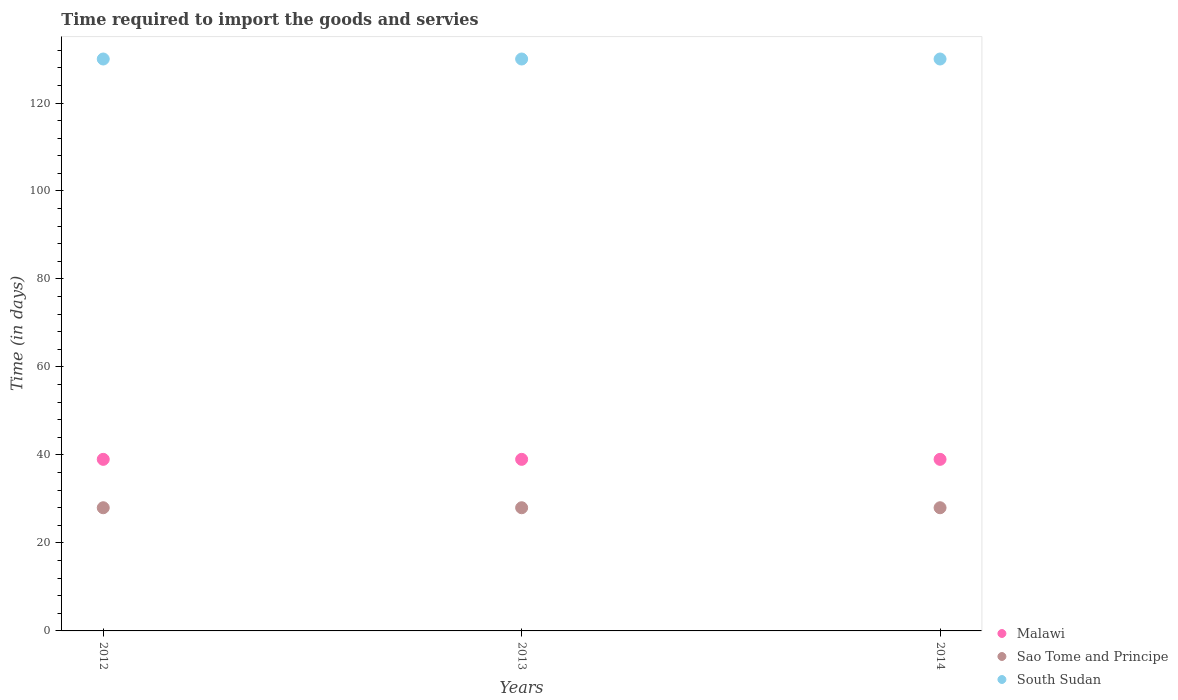How many different coloured dotlines are there?
Provide a short and direct response. 3. Is the number of dotlines equal to the number of legend labels?
Provide a short and direct response. Yes. What is the number of days required to import the goods and services in Malawi in 2014?
Your answer should be compact. 39. Across all years, what is the maximum number of days required to import the goods and services in South Sudan?
Your answer should be compact. 130. Across all years, what is the minimum number of days required to import the goods and services in South Sudan?
Give a very brief answer. 130. What is the total number of days required to import the goods and services in Sao Tome and Principe in the graph?
Offer a terse response. 84. What is the difference between the number of days required to import the goods and services in South Sudan in 2013 and that in 2014?
Make the answer very short. 0. What is the difference between the number of days required to import the goods and services in Malawi in 2014 and the number of days required to import the goods and services in Sao Tome and Principe in 2012?
Ensure brevity in your answer.  11. What is the average number of days required to import the goods and services in Sao Tome and Principe per year?
Offer a very short reply. 28. In the year 2012, what is the difference between the number of days required to import the goods and services in Malawi and number of days required to import the goods and services in South Sudan?
Provide a succinct answer. -91. Is the sum of the number of days required to import the goods and services in Malawi in 2012 and 2013 greater than the maximum number of days required to import the goods and services in Sao Tome and Principe across all years?
Provide a succinct answer. Yes. Is the number of days required to import the goods and services in Sao Tome and Principe strictly less than the number of days required to import the goods and services in South Sudan over the years?
Your answer should be compact. Yes. How many years are there in the graph?
Your answer should be compact. 3. What is the difference between two consecutive major ticks on the Y-axis?
Give a very brief answer. 20. Does the graph contain any zero values?
Make the answer very short. No. Where does the legend appear in the graph?
Ensure brevity in your answer.  Bottom right. How are the legend labels stacked?
Keep it short and to the point. Vertical. What is the title of the graph?
Offer a terse response. Time required to import the goods and servies. Does "Bangladesh" appear as one of the legend labels in the graph?
Offer a very short reply. No. What is the label or title of the X-axis?
Your response must be concise. Years. What is the label or title of the Y-axis?
Make the answer very short. Time (in days). What is the Time (in days) in Malawi in 2012?
Keep it short and to the point. 39. What is the Time (in days) in Sao Tome and Principe in 2012?
Make the answer very short. 28. What is the Time (in days) of South Sudan in 2012?
Ensure brevity in your answer.  130. What is the Time (in days) in Malawi in 2013?
Your answer should be compact. 39. What is the Time (in days) in Sao Tome and Principe in 2013?
Your answer should be very brief. 28. What is the Time (in days) in South Sudan in 2013?
Your answer should be very brief. 130. What is the Time (in days) of Malawi in 2014?
Keep it short and to the point. 39. What is the Time (in days) in Sao Tome and Principe in 2014?
Offer a very short reply. 28. What is the Time (in days) in South Sudan in 2014?
Keep it short and to the point. 130. Across all years, what is the maximum Time (in days) in Sao Tome and Principe?
Offer a very short reply. 28. Across all years, what is the maximum Time (in days) of South Sudan?
Your answer should be compact. 130. Across all years, what is the minimum Time (in days) of Malawi?
Make the answer very short. 39. Across all years, what is the minimum Time (in days) in Sao Tome and Principe?
Offer a very short reply. 28. Across all years, what is the minimum Time (in days) in South Sudan?
Provide a succinct answer. 130. What is the total Time (in days) of Malawi in the graph?
Offer a terse response. 117. What is the total Time (in days) in Sao Tome and Principe in the graph?
Ensure brevity in your answer.  84. What is the total Time (in days) of South Sudan in the graph?
Provide a short and direct response. 390. What is the difference between the Time (in days) of Malawi in 2012 and that in 2013?
Offer a terse response. 0. What is the difference between the Time (in days) in South Sudan in 2012 and that in 2013?
Provide a short and direct response. 0. What is the difference between the Time (in days) of Malawi in 2012 and that in 2014?
Offer a terse response. 0. What is the difference between the Time (in days) of South Sudan in 2012 and that in 2014?
Offer a very short reply. 0. What is the difference between the Time (in days) in Malawi in 2013 and that in 2014?
Provide a succinct answer. 0. What is the difference between the Time (in days) in Malawi in 2012 and the Time (in days) in Sao Tome and Principe in 2013?
Ensure brevity in your answer.  11. What is the difference between the Time (in days) in Malawi in 2012 and the Time (in days) in South Sudan in 2013?
Your answer should be compact. -91. What is the difference between the Time (in days) of Sao Tome and Principe in 2012 and the Time (in days) of South Sudan in 2013?
Keep it short and to the point. -102. What is the difference between the Time (in days) of Malawi in 2012 and the Time (in days) of South Sudan in 2014?
Offer a terse response. -91. What is the difference between the Time (in days) in Sao Tome and Principe in 2012 and the Time (in days) in South Sudan in 2014?
Offer a very short reply. -102. What is the difference between the Time (in days) of Malawi in 2013 and the Time (in days) of Sao Tome and Principe in 2014?
Provide a succinct answer. 11. What is the difference between the Time (in days) in Malawi in 2013 and the Time (in days) in South Sudan in 2014?
Provide a short and direct response. -91. What is the difference between the Time (in days) in Sao Tome and Principe in 2013 and the Time (in days) in South Sudan in 2014?
Offer a very short reply. -102. What is the average Time (in days) of Malawi per year?
Provide a short and direct response. 39. What is the average Time (in days) of Sao Tome and Principe per year?
Make the answer very short. 28. What is the average Time (in days) in South Sudan per year?
Keep it short and to the point. 130. In the year 2012, what is the difference between the Time (in days) in Malawi and Time (in days) in Sao Tome and Principe?
Offer a very short reply. 11. In the year 2012, what is the difference between the Time (in days) of Malawi and Time (in days) of South Sudan?
Keep it short and to the point. -91. In the year 2012, what is the difference between the Time (in days) in Sao Tome and Principe and Time (in days) in South Sudan?
Keep it short and to the point. -102. In the year 2013, what is the difference between the Time (in days) in Malawi and Time (in days) in South Sudan?
Your answer should be compact. -91. In the year 2013, what is the difference between the Time (in days) in Sao Tome and Principe and Time (in days) in South Sudan?
Offer a terse response. -102. In the year 2014, what is the difference between the Time (in days) of Malawi and Time (in days) of Sao Tome and Principe?
Keep it short and to the point. 11. In the year 2014, what is the difference between the Time (in days) in Malawi and Time (in days) in South Sudan?
Give a very brief answer. -91. In the year 2014, what is the difference between the Time (in days) in Sao Tome and Principe and Time (in days) in South Sudan?
Your response must be concise. -102. What is the ratio of the Time (in days) of Malawi in 2012 to that in 2013?
Give a very brief answer. 1. What is the ratio of the Time (in days) of Sao Tome and Principe in 2012 to that in 2014?
Provide a short and direct response. 1. What is the ratio of the Time (in days) of South Sudan in 2012 to that in 2014?
Your answer should be very brief. 1. What is the difference between the highest and the second highest Time (in days) of Sao Tome and Principe?
Provide a succinct answer. 0. What is the difference between the highest and the second highest Time (in days) of South Sudan?
Ensure brevity in your answer.  0. What is the difference between the highest and the lowest Time (in days) of Malawi?
Give a very brief answer. 0. What is the difference between the highest and the lowest Time (in days) of South Sudan?
Ensure brevity in your answer.  0. 